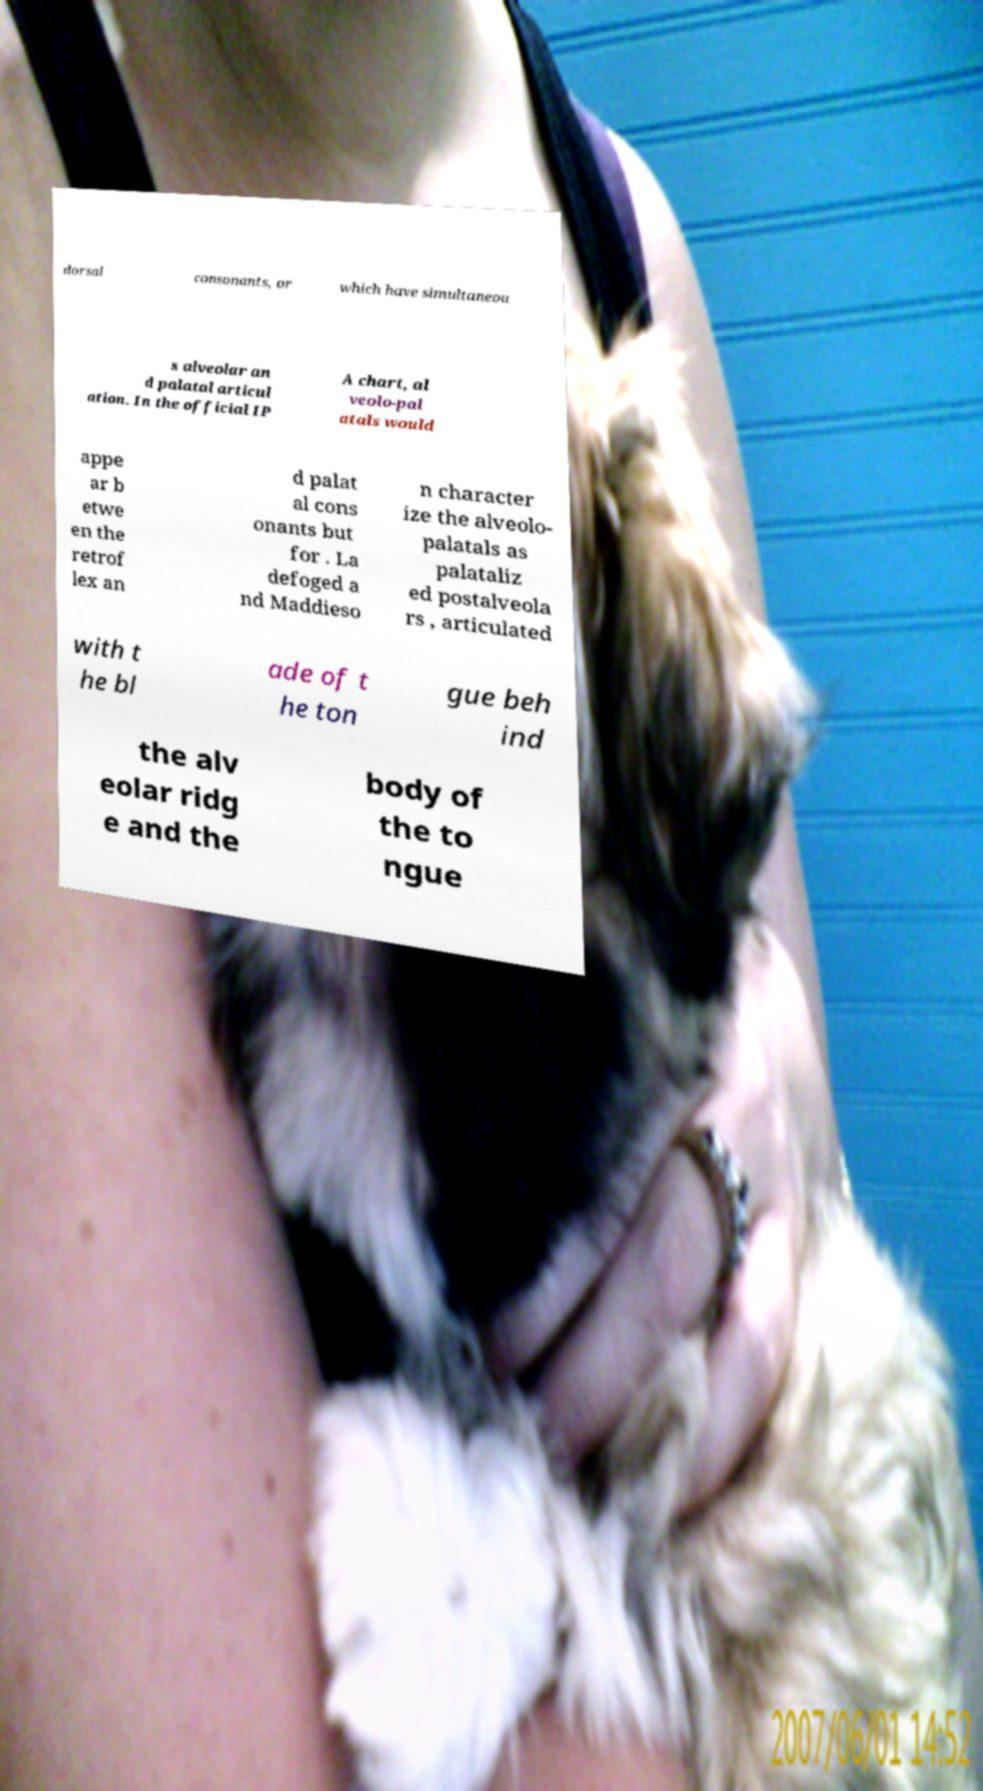Can you accurately transcribe the text from the provided image for me? dorsal consonants, or which have simultaneou s alveolar an d palatal articul ation. In the official IP A chart, al veolo-pal atals would appe ar b etwe en the retrof lex an d palat al cons onants but for . La defoged a nd Maddieso n character ize the alveolo- palatals as palataliz ed postalveola rs , articulated with t he bl ade of t he ton gue beh ind the alv eolar ridg e and the body of the to ngue 